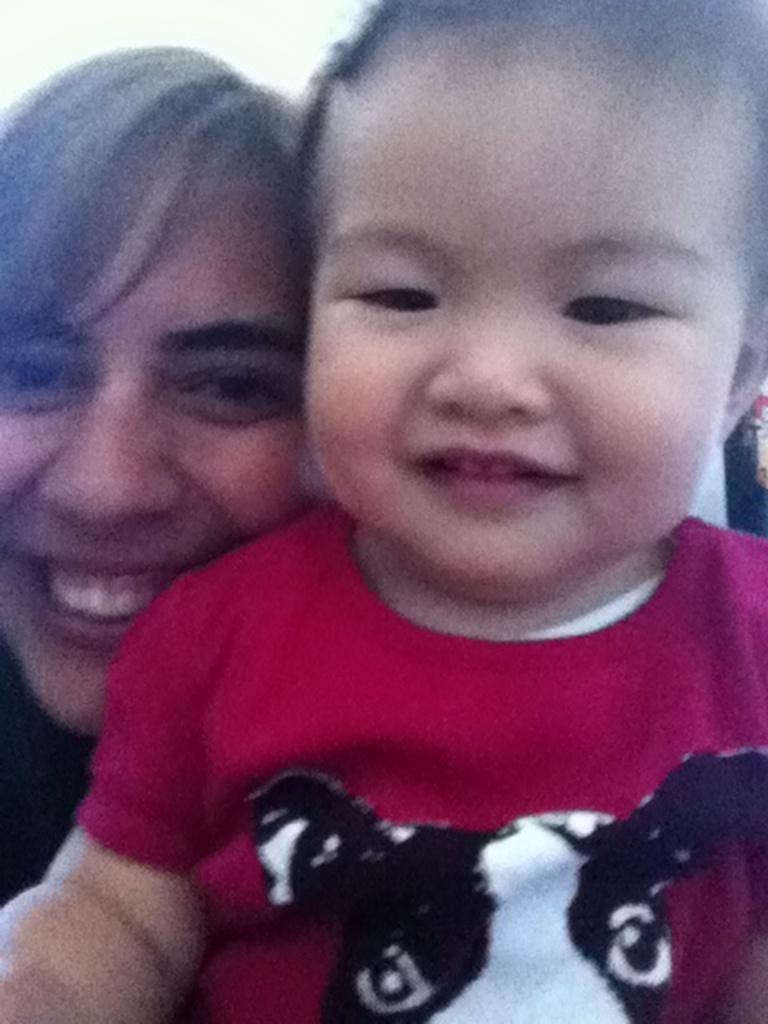Who is present in the image? There is a woman and a child in the image. What is the emotional state of the woman in the image? The woman is smiling in the image. What is the emotional state of the child in the image? The child is smiling in the image. What type of holiday is being celebrated in the image? There is no indication of a holiday being celebrated in the image. Can you see a volcano in the background of the image? There is no volcano present in the image. 